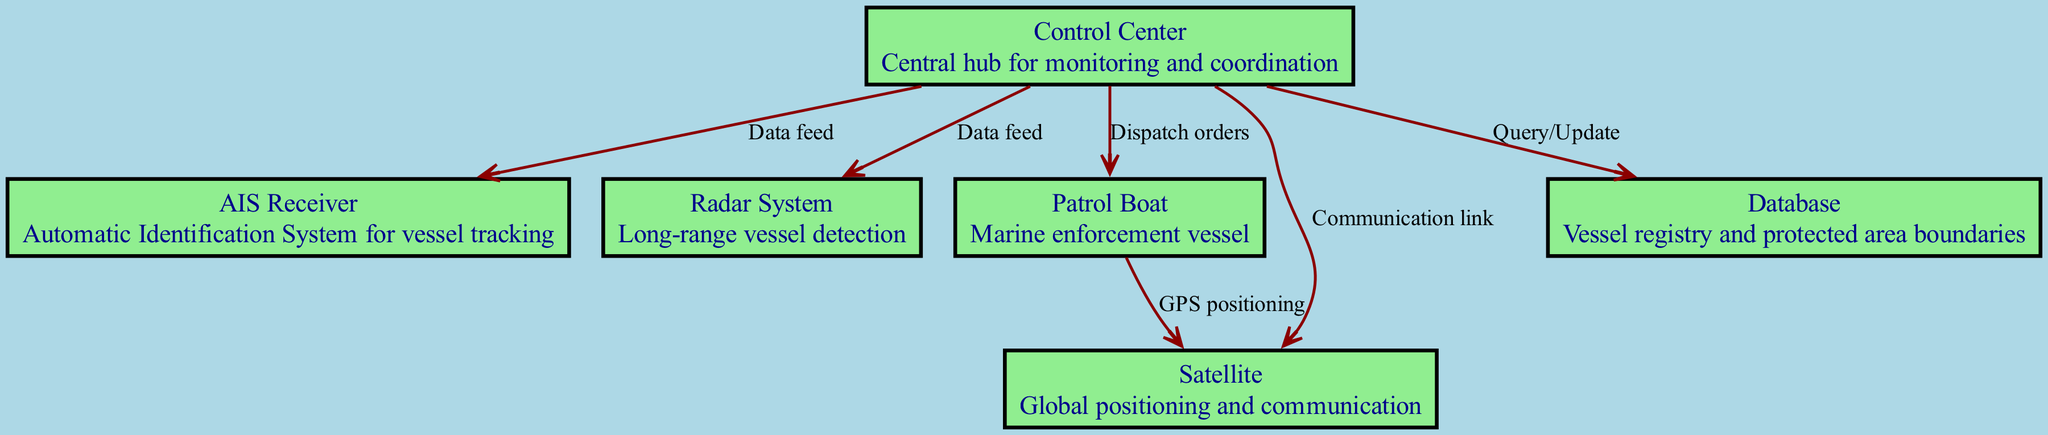What is the central hub for monitoring and coordination? The control center is indicated as the primary node responsible for overseeing operations and coordination among the various systems.
Answer: Control Center How many nodes are present in the diagram? By counting the different labeled boxes in the diagram, we find a total of six distinct nodes related to the vessel tracking and identification system.
Answer: 6 What type of link connects the Control Center to the Patrol Boat? The connection between these two nodes is labeled as "Dispatch orders," indicating that the Control Center sends instructions to the Patrol Boat.
Answer: Dispatch orders Which system is involved in long-range vessel detection? The diagram identifies the Radar System as the component specifically designed to detect vessels at a long range.
Answer: Radar System What communication capability does the Control Center have with the Satellite? The diagram specifies a "Communication link" between the Control Center and the Satellite, indicating their functional relationship for data exchange.
Answer: Communication link What does the Patrol Boat utilize for GPS positioning? The diagram indicates that the Patrol Boat uses the Satellite for GPS positioning, showcasing a direct connection between these two components.
Answer: GPS positioning Which node represents the vessel registry and protected area boundaries? The Database in the diagram is designated to manage and store information pertaining to the vessel registry and protected area limits.
Answer: Database What is the type of data feed the Control Center receives from the AIS Receiver? The Control Center receives vessel tracking data from the AIS Receiver, as represented by the labeled edge connecting the two nodes.
Answer: Data feed From which node does the Radar System receive data? The Control Center is linked to the Radar System with a "Data feed," making it the source of information for the Radar System.
Answer: Control Center What is the relationship between the Patrol Boat and the Satellite regarding positioning? The relationship is described as "GPS positioning," signifying that the Patrol Boat relies on the Satellite for its geographic location and navigation.
Answer: GPS positioning 